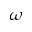Convert formula to latex. <formula><loc_0><loc_0><loc_500><loc_500>\omega</formula> 